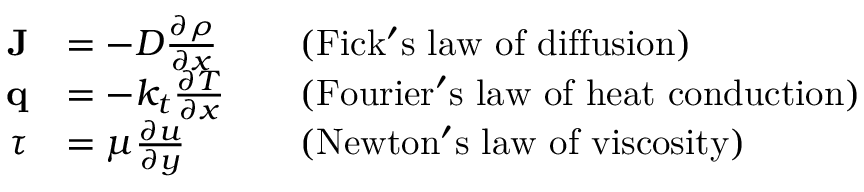<formula> <loc_0><loc_0><loc_500><loc_500>{ \begin{array} { r l r l } { J } & { = - D { \frac { \partial \rho } { \partial x } } } & & { ( F i c k ^ { \prime } s l a w o f d i f f u s i o n ) } \\ { q } & { = - k _ { t } { \frac { \partial T } { \partial x } } } & & { ( F o u r i e r ^ { \prime } s l a w o f h e a t c o n d u c t i o n ) } \\ { \tau } & { = \mu { \frac { \partial u } { \partial y } } } & & { ( N e w t o n ^ { \prime } s l a w o f v i s \cos i t y ) } \end{array} }</formula> 